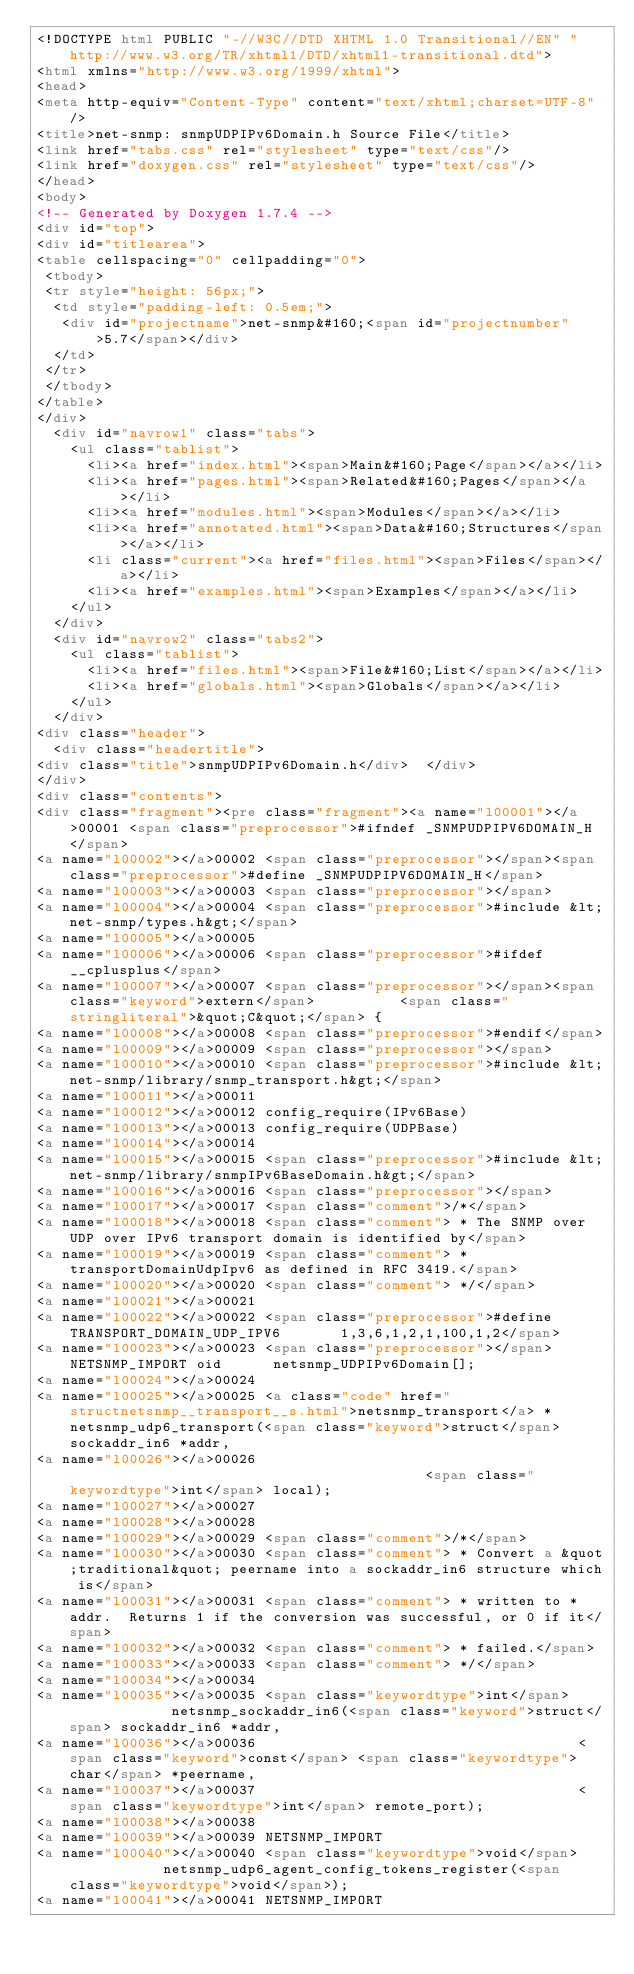Convert code to text. <code><loc_0><loc_0><loc_500><loc_500><_HTML_><!DOCTYPE html PUBLIC "-//W3C//DTD XHTML 1.0 Transitional//EN" "http://www.w3.org/TR/xhtml1/DTD/xhtml1-transitional.dtd">
<html xmlns="http://www.w3.org/1999/xhtml">
<head>
<meta http-equiv="Content-Type" content="text/xhtml;charset=UTF-8"/>
<title>net-snmp: snmpUDPIPv6Domain.h Source File</title>
<link href="tabs.css" rel="stylesheet" type="text/css"/>
<link href="doxygen.css" rel="stylesheet" type="text/css"/>
</head>
<body>
<!-- Generated by Doxygen 1.7.4 -->
<div id="top">
<div id="titlearea">
<table cellspacing="0" cellpadding="0">
 <tbody>
 <tr style="height: 56px;">
  <td style="padding-left: 0.5em;">
   <div id="projectname">net-snmp&#160;<span id="projectnumber">5.7</span></div>
  </td>
 </tr>
 </tbody>
</table>
</div>
  <div id="navrow1" class="tabs">
    <ul class="tablist">
      <li><a href="index.html"><span>Main&#160;Page</span></a></li>
      <li><a href="pages.html"><span>Related&#160;Pages</span></a></li>
      <li><a href="modules.html"><span>Modules</span></a></li>
      <li><a href="annotated.html"><span>Data&#160;Structures</span></a></li>
      <li class="current"><a href="files.html"><span>Files</span></a></li>
      <li><a href="examples.html"><span>Examples</span></a></li>
    </ul>
  </div>
  <div id="navrow2" class="tabs2">
    <ul class="tablist">
      <li><a href="files.html"><span>File&#160;List</span></a></li>
      <li><a href="globals.html"><span>Globals</span></a></li>
    </ul>
  </div>
<div class="header">
  <div class="headertitle">
<div class="title">snmpUDPIPv6Domain.h</div>  </div>
</div>
<div class="contents">
<div class="fragment"><pre class="fragment"><a name="l00001"></a>00001 <span class="preprocessor">#ifndef _SNMPUDPIPV6DOMAIN_H</span>
<a name="l00002"></a>00002 <span class="preprocessor"></span><span class="preprocessor">#define _SNMPUDPIPV6DOMAIN_H</span>
<a name="l00003"></a>00003 <span class="preprocessor"></span>
<a name="l00004"></a>00004 <span class="preprocessor">#include &lt;net-snmp/types.h&gt;</span>
<a name="l00005"></a>00005 
<a name="l00006"></a>00006 <span class="preprocessor">#ifdef __cplusplus</span>
<a name="l00007"></a>00007 <span class="preprocessor"></span><span class="keyword">extern</span>          <span class="stringliteral">&quot;C&quot;</span> {
<a name="l00008"></a>00008 <span class="preprocessor">#endif</span>
<a name="l00009"></a>00009 <span class="preprocessor"></span>
<a name="l00010"></a>00010 <span class="preprocessor">#include &lt;net-snmp/library/snmp_transport.h&gt;</span>
<a name="l00011"></a>00011 
<a name="l00012"></a>00012 config_require(IPv6Base)
<a name="l00013"></a>00013 config_require(UDPBase)
<a name="l00014"></a>00014 
<a name="l00015"></a>00015 <span class="preprocessor">#include &lt;net-snmp/library/snmpIPv6BaseDomain.h&gt;</span>
<a name="l00016"></a>00016 <span class="preprocessor"></span>
<a name="l00017"></a>00017 <span class="comment">/*</span>
<a name="l00018"></a>00018 <span class="comment"> * The SNMP over UDP over IPv6 transport domain is identified by</span>
<a name="l00019"></a>00019 <span class="comment"> * transportDomainUdpIpv6 as defined in RFC 3419.</span>
<a name="l00020"></a>00020 <span class="comment"> */</span>
<a name="l00021"></a>00021 
<a name="l00022"></a>00022 <span class="preprocessor">#define TRANSPORT_DOMAIN_UDP_IPV6       1,3,6,1,2,1,100,1,2</span>
<a name="l00023"></a>00023 <span class="preprocessor"></span>NETSNMP_IMPORT oid      netsnmp_UDPIPv6Domain[];
<a name="l00024"></a>00024 
<a name="l00025"></a>00025 <a class="code" href="structnetsnmp__transport__s.html">netsnmp_transport</a> *netsnmp_udp6_transport(<span class="keyword">struct</span> sockaddr_in6 *addr,
<a name="l00026"></a>00026                                           <span class="keywordtype">int</span> local);
<a name="l00027"></a>00027 
<a name="l00028"></a>00028 
<a name="l00029"></a>00029 <span class="comment">/*</span>
<a name="l00030"></a>00030 <span class="comment"> * Convert a &quot;traditional&quot; peername into a sockaddr_in6 structure which is</span>
<a name="l00031"></a>00031 <span class="comment"> * written to *addr.  Returns 1 if the conversion was successful, or 0 if it</span>
<a name="l00032"></a>00032 <span class="comment"> * failed.</span>
<a name="l00033"></a>00033 <span class="comment"> */</span>
<a name="l00034"></a>00034 
<a name="l00035"></a>00035 <span class="keywordtype">int</span>             netsnmp_sockaddr_in6(<span class="keyword">struct</span> sockaddr_in6 *addr,
<a name="l00036"></a>00036                                      <span class="keyword">const</span> <span class="keywordtype">char</span> *peername,
<a name="l00037"></a>00037                                      <span class="keywordtype">int</span> remote_port);
<a name="l00038"></a>00038 
<a name="l00039"></a>00039 NETSNMP_IMPORT
<a name="l00040"></a>00040 <span class="keywordtype">void</span>            netsnmp_udp6_agent_config_tokens_register(<span class="keywordtype">void</span>);
<a name="l00041"></a>00041 NETSNMP_IMPORT</code> 